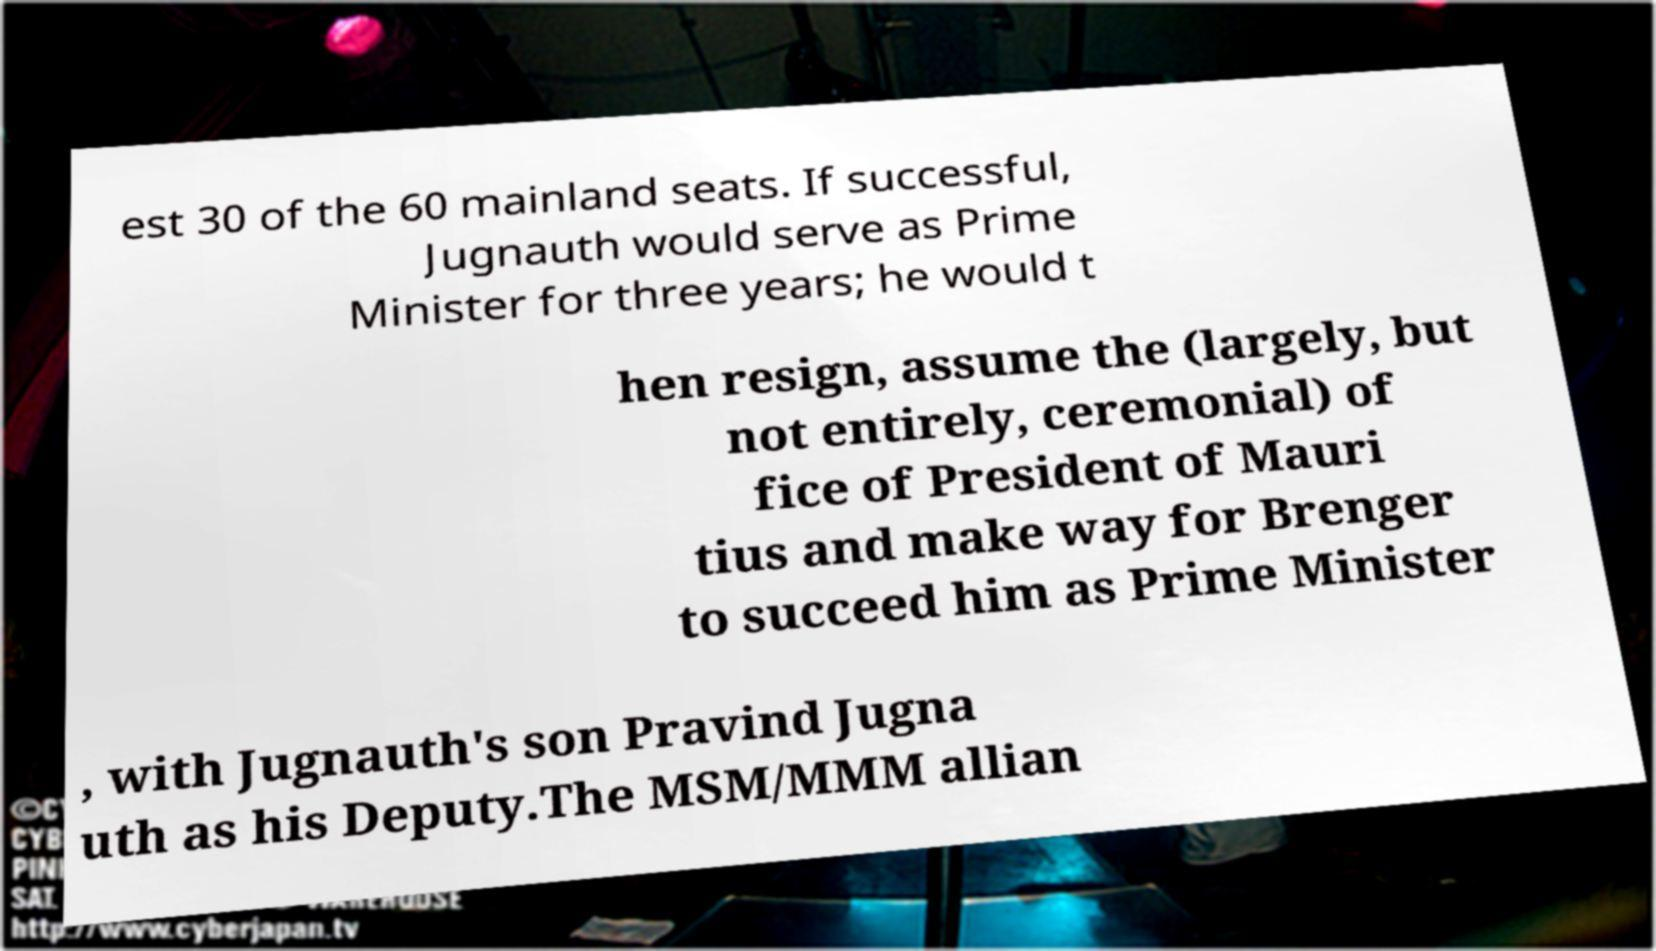Please read and relay the text visible in this image. What does it say? est 30 of the 60 mainland seats. If successful, Jugnauth would serve as Prime Minister for three years; he would t hen resign, assume the (largely, but not entirely, ceremonial) of fice of President of Mauri tius and make way for Brenger to succeed him as Prime Minister , with Jugnauth's son Pravind Jugna uth as his Deputy.The MSM/MMM allian 